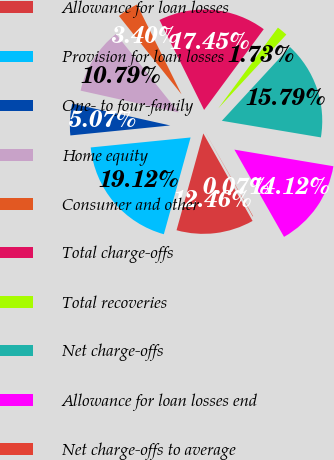Convert chart to OTSL. <chart><loc_0><loc_0><loc_500><loc_500><pie_chart><fcel>Allowance for loan losses<fcel>Provision for loan losses<fcel>One- to four-family<fcel>Home equity<fcel>Consumer and other<fcel>Total charge-offs<fcel>Total recoveries<fcel>Net charge-offs<fcel>Allowance for loan losses end<fcel>Net charge-offs to average<nl><fcel>12.46%<fcel>19.12%<fcel>5.07%<fcel>10.79%<fcel>3.4%<fcel>17.45%<fcel>1.73%<fcel>15.79%<fcel>14.12%<fcel>0.07%<nl></chart> 